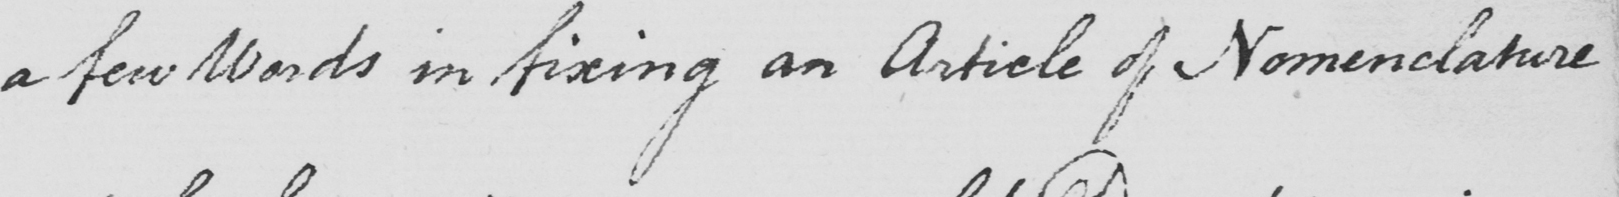What text is written in this handwritten line? a few Words in fixing an Article of Nomenclature 